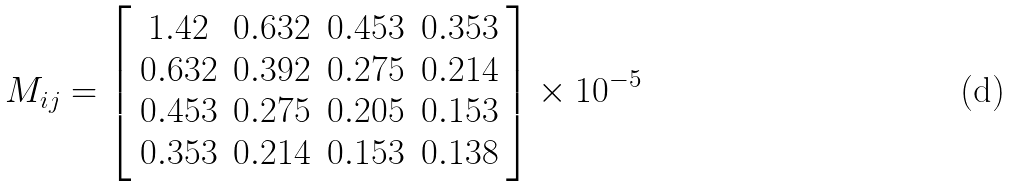Convert formula to latex. <formula><loc_0><loc_0><loc_500><loc_500>M _ { i j } = \left [ \begin{array} { c c c c } 1 . 4 2 & 0 . 6 3 2 & 0 . 4 5 3 & 0 . 3 5 3 \\ 0 . 6 3 2 & 0 . 3 9 2 & 0 . 2 7 5 & 0 . 2 1 4 \\ 0 . 4 5 3 & 0 . 2 7 5 & 0 . 2 0 5 & 0 . 1 5 3 \\ 0 . 3 5 3 & 0 . 2 1 4 & 0 . 1 5 3 & 0 . 1 3 8 \end{array} \right ] \times 1 0 ^ { - 5 }</formula> 